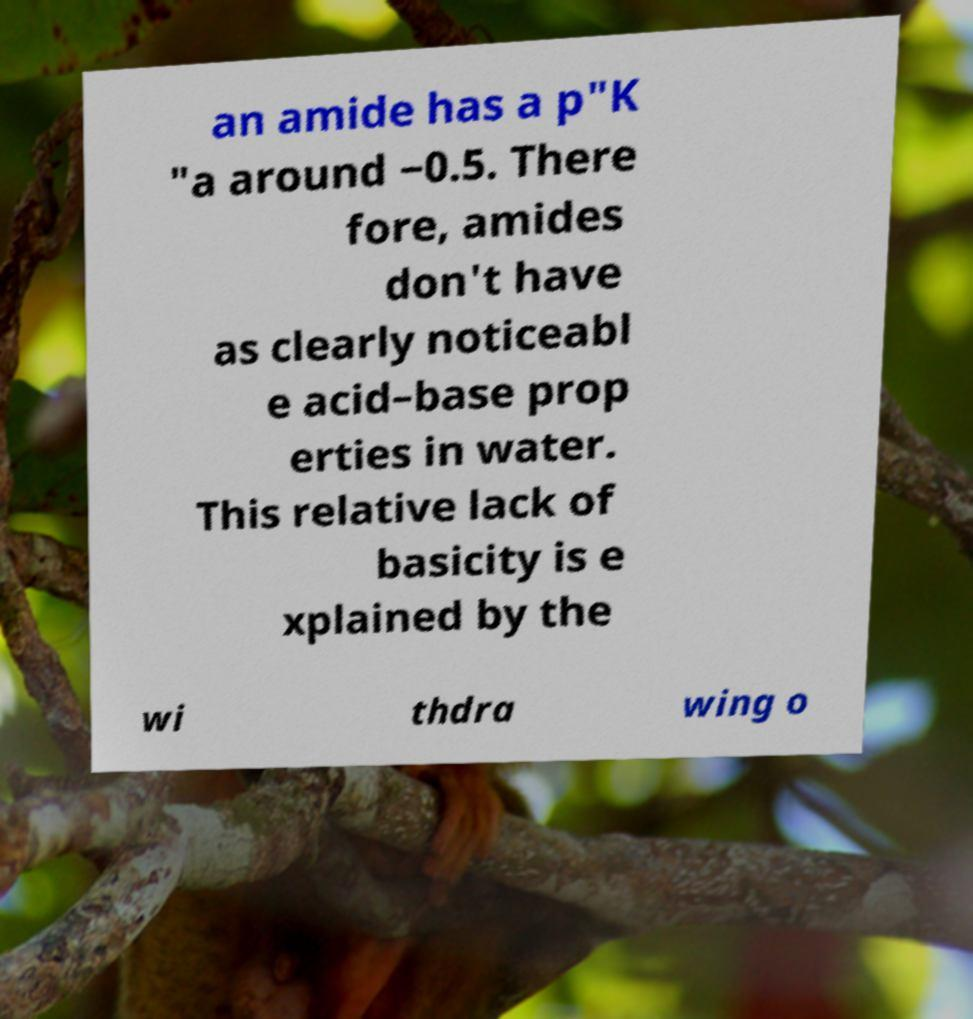What messages or text are displayed in this image? I need them in a readable, typed format. an amide has a p"K "a around −0.5. There fore, amides don't have as clearly noticeabl e acid–base prop erties in water. This relative lack of basicity is e xplained by the wi thdra wing o 